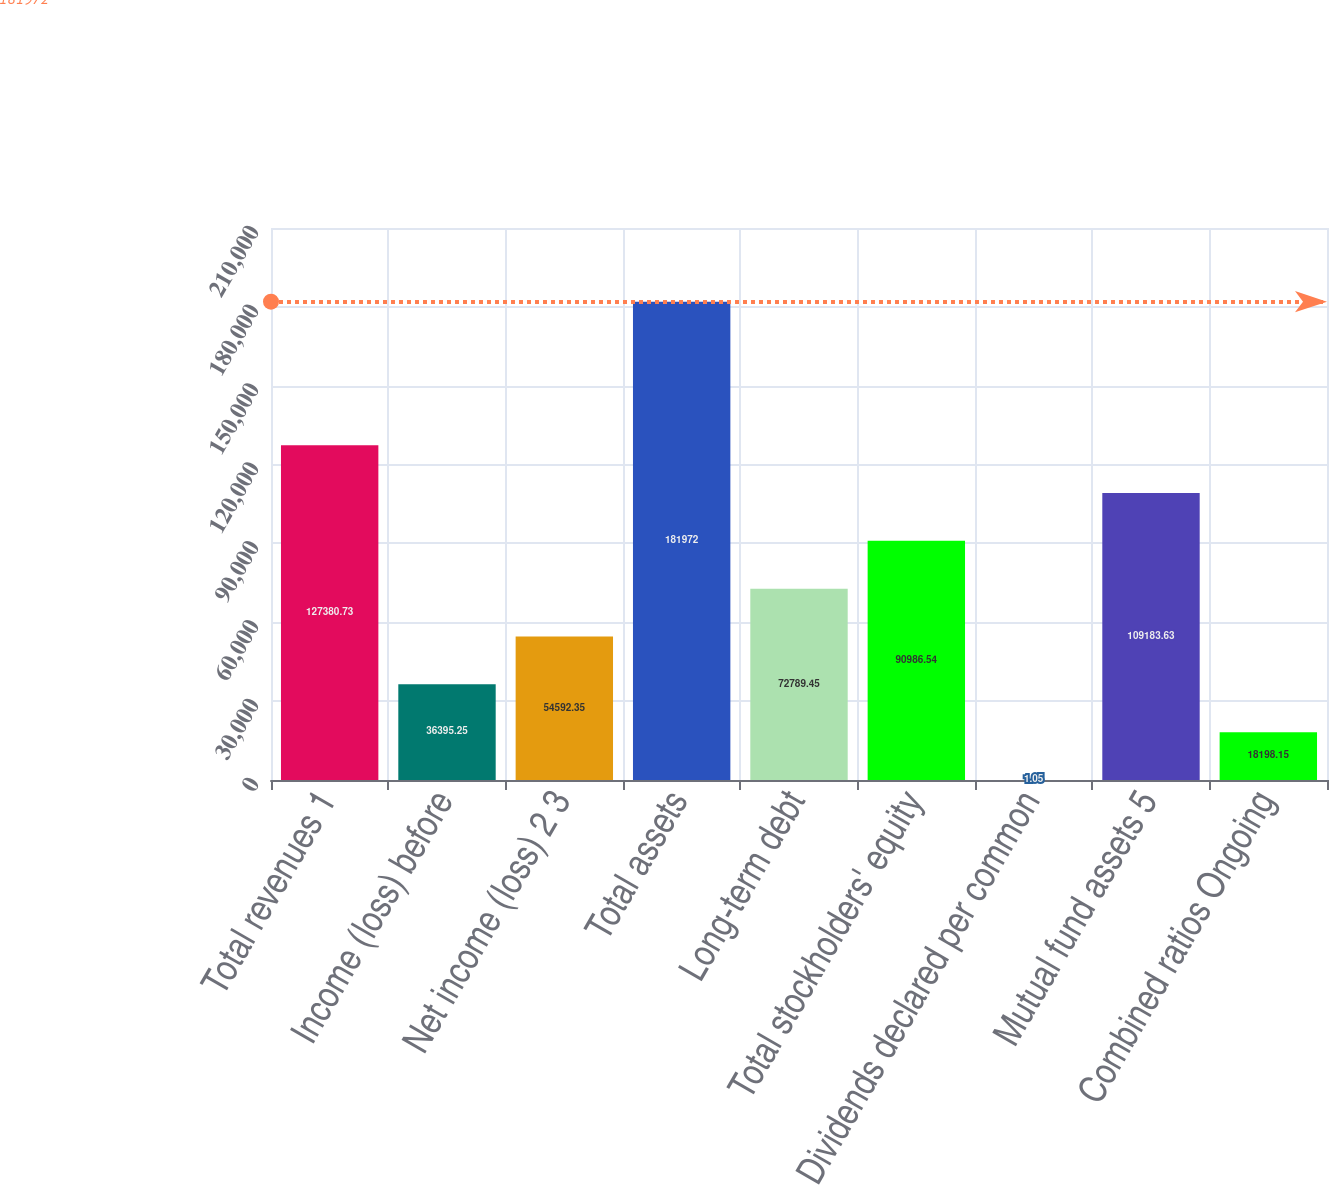Convert chart. <chart><loc_0><loc_0><loc_500><loc_500><bar_chart><fcel>Total revenues 1<fcel>Income (loss) before<fcel>Net income (loss) 2 3<fcel>Total assets<fcel>Long-term debt<fcel>Total stockholders' equity<fcel>Dividends declared per common<fcel>Mutual fund assets 5<fcel>Combined ratios Ongoing<nl><fcel>127381<fcel>36395.2<fcel>54592.3<fcel>181972<fcel>72789.4<fcel>90986.5<fcel>1.05<fcel>109184<fcel>18198.2<nl></chart> 